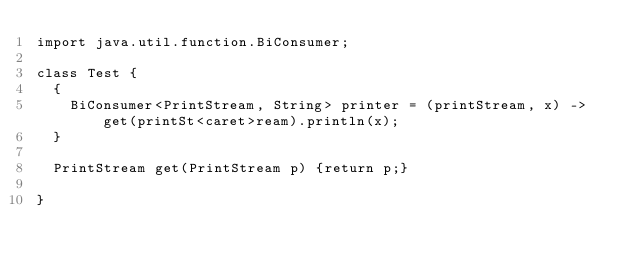Convert code to text. <code><loc_0><loc_0><loc_500><loc_500><_Java_>import java.util.function.BiConsumer;

class Test {
  {
    BiConsumer<PrintStream, String> printer = (printStream, x) -> get(printSt<caret>ream).println(x);
  }

  PrintStream get(PrintStream p) {return p;}

}
</code> 